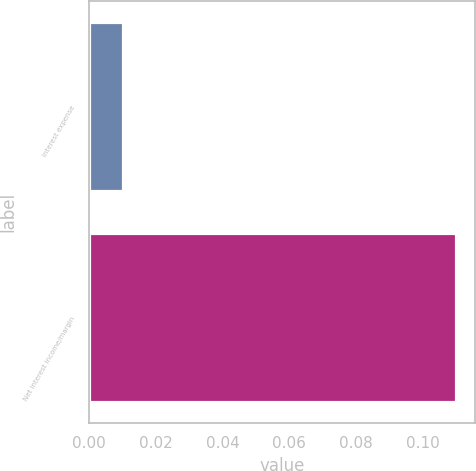Convert chart. <chart><loc_0><loc_0><loc_500><loc_500><bar_chart><fcel>Interest expense<fcel>Net interest income/margin<nl><fcel>0.01<fcel>0.11<nl></chart> 